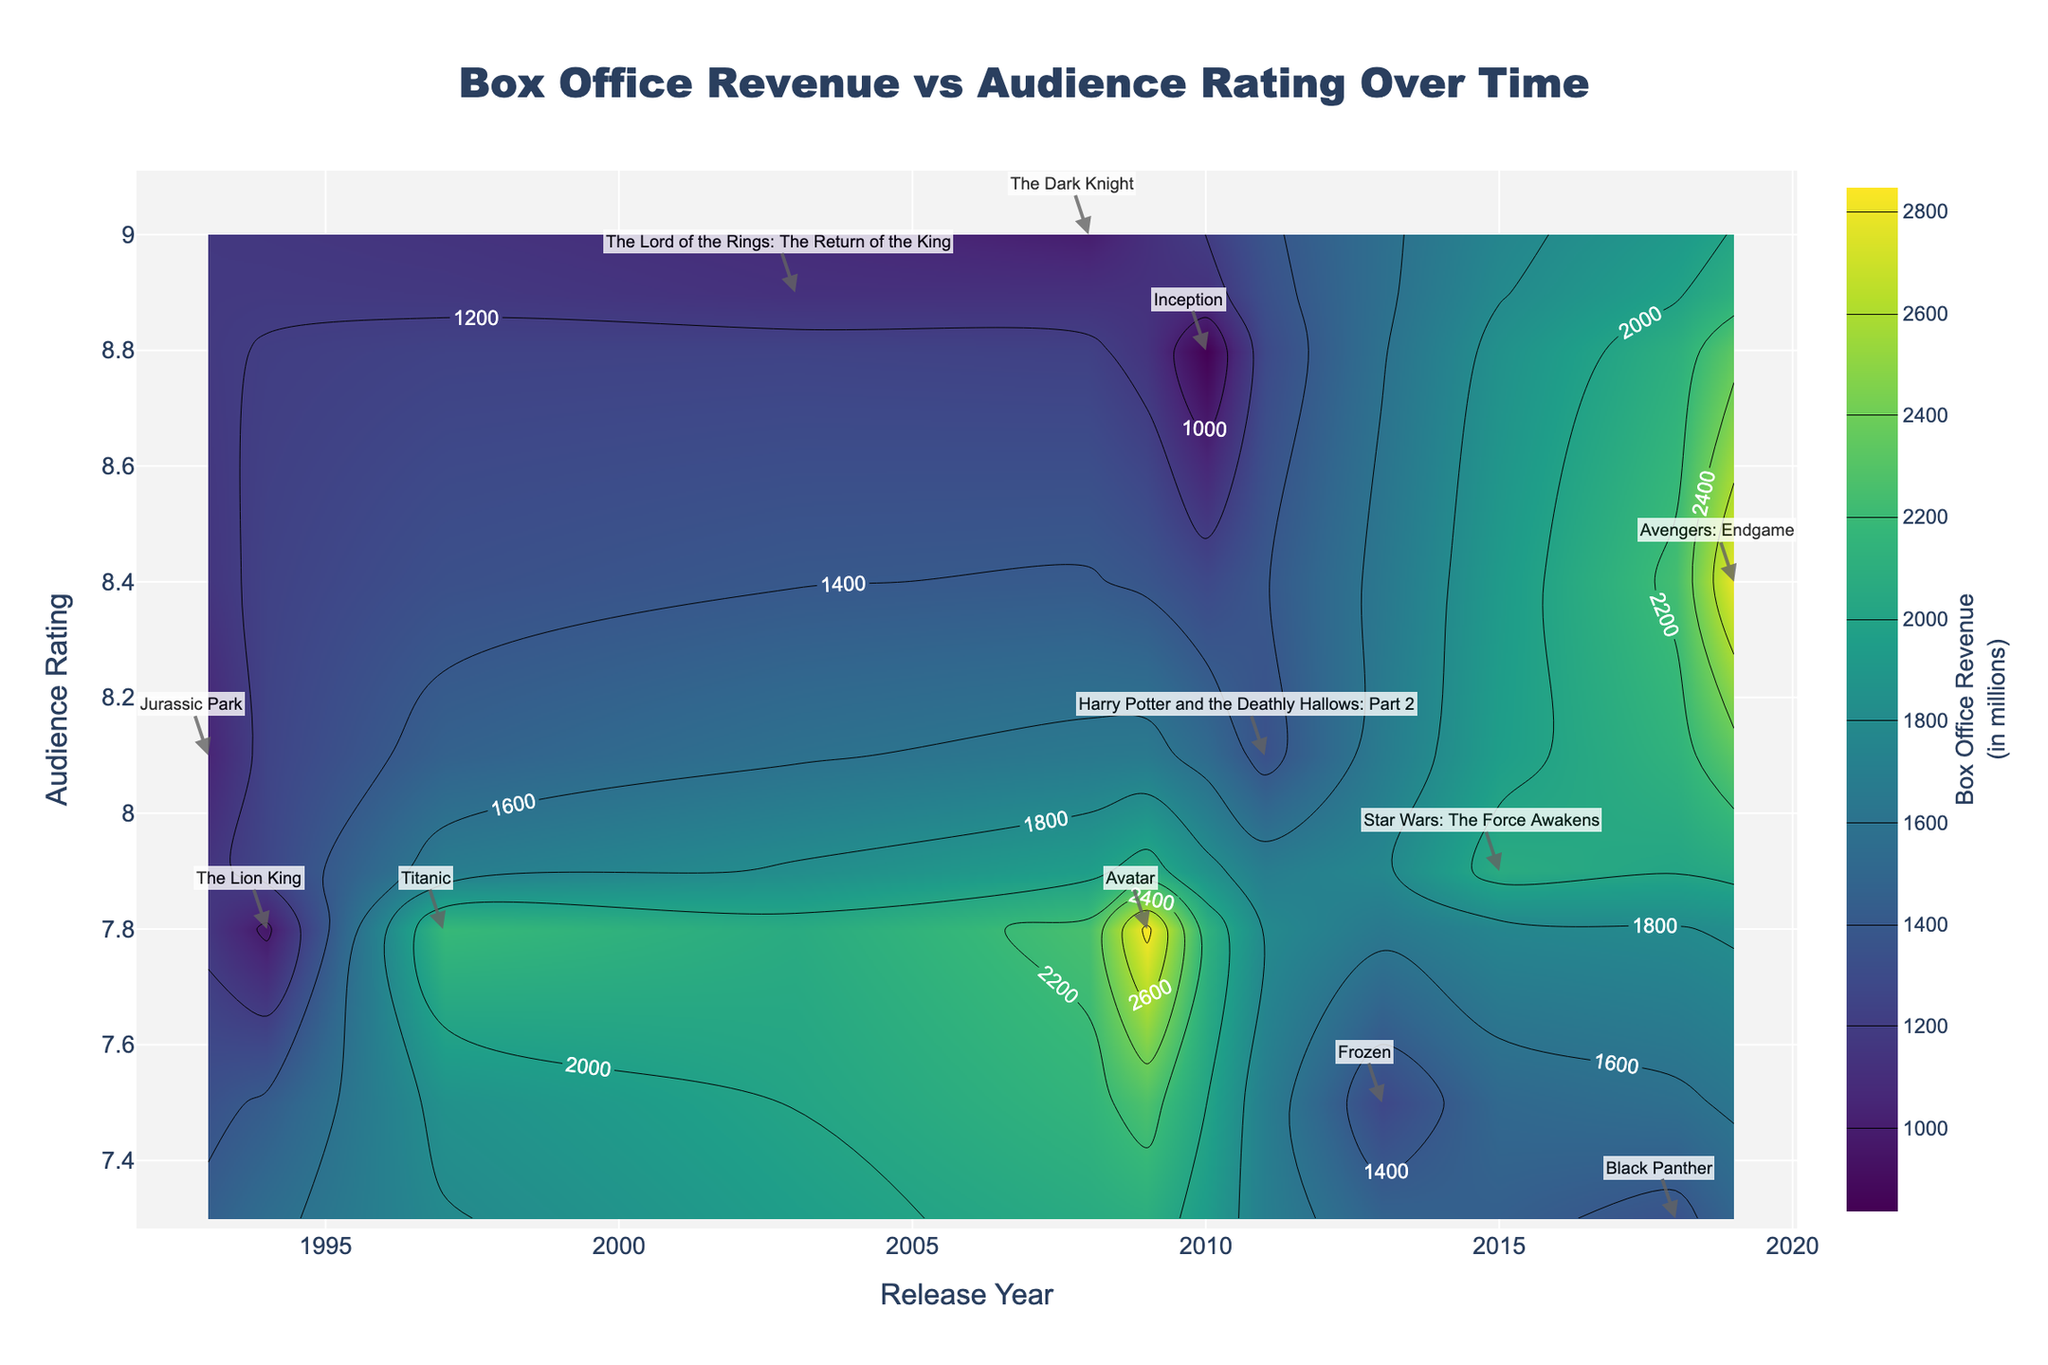What's the title of the figure? The title is positioned prominently at the top of the figure. It usually provides an overview of the entire plot. In this case, it reads "Box Office Revenue vs Audience Rating Over Time".
Answer: Box Office Revenue vs Audience Rating Over Time What color represents higher box office revenue? Higher values on a contour plot are indicated with different coloring based on the color scale. Here, the colors are depicted with a 'Viridis' scale, so, typically, the greener or yellower sections represent higher revenues.
Answer: Green/Yellow Which movie has the highest box office revenue and what is its audience rating? From the annotations and z-axis (box office revenue) data, the movie "Avatar" has the highest revenue of 2847 million. According to the y-axis, its audience rating is 7.8.
Answer: Avatar, 7.8 Which year had the most movies represented in the figure? By looking at the x-axis and checking the annotations for the number of movies per year, 2011 and 2018 both have one movie each ("Harry Potter and the Deathly Hallows: Part 2" and "Black Panther", respectively). However, it might seem that the year with the highest quantity is 2019, "Avengers: Endgame". This visually indicates the peak release year in terms of count for these blockbusters.
Answer: 2019 Which movie had the lowest audience rating yet high box office revenue? Examine the y-axis for the lowest audience rating and cross-reference with the corresponding box office revenue. "Black Panther" has a lower audience rating of 7.3 but still has a high box office revenue of 1347 million.
Answer: Black Panther What is the audience rating of "The Dark Knight"? Locate "The Dark Knight" on the plot. From the y-axis annotation, the audience rating is 9.0.
Answer: 9.0 Which movie had the closest box office revenue to "The Lion King"? Compare the 'Box Office Revenue (in millions)' values by checking contours around the "The Lion King" annotation. "Jurassic Park" has a revenue of 1043 million, close to "The Lion King"'s 968 million.
Answer: Jurassic Park What trend can be inferred about audience ratings over the years? By inspecting the contour plot's general direction and audience rating annotations across years, there is no definitive increasing nor decreasing trend. However, many high box office revenue movies with good ratings appear scattered across different years.
Answer: No clear trend How does "The Lord of the Rings: The Return of the King" compare with "Inception" in terms of audience rating and revenue? "The Lord of the Rings: The Return of the King" has an audience rating of 8.9 and revenue of 1120 million, while "Inception" has a rating of 8.8 and revenue of 836 million.
Answer: Higher rating, higher revenue In which decade were the movies achieving the highest box office revenue released? By assessing the x-axis labels and noting the annotations of high revenue movies such as "Avatar" and "Avengers: Endgame," most high revenue movies seem to cluster in the 2000s and 2010s.
Answer: 2000s and 2010s 